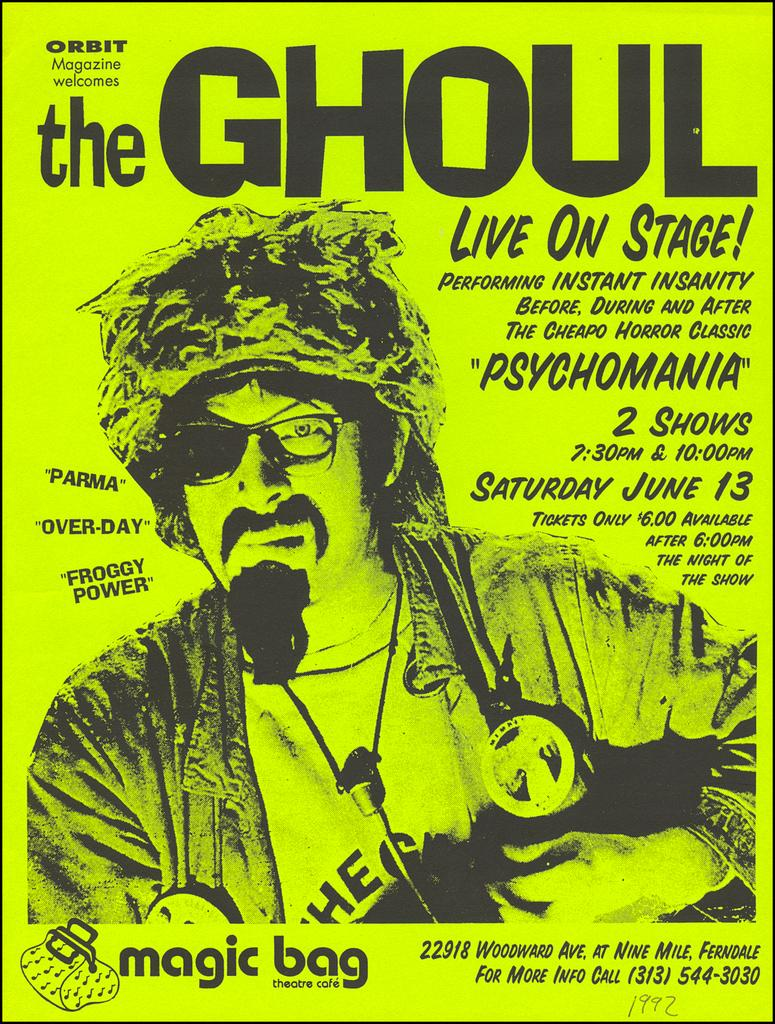What is present on the poster in the image? The poster contains text, an image, and numbers. Can you describe the image on the poster? Unfortunately, the specific image on the poster cannot be described without more information. What type of information is conveyed by the text on the poster? The content of the text on the poster cannot be determined without more information. Where is the plastic vase located in the image? There is no plastic vase present in the image. Can you describe the skateboarding skills of the person in the image? There is no person or skateboarding activity present in the image. 